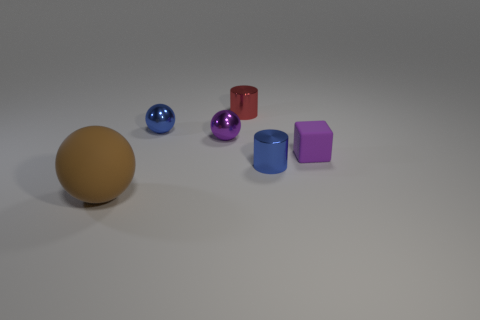Add 1 tiny purple objects. How many objects exist? 7 Subtract all blocks. How many objects are left? 5 Add 6 large rubber spheres. How many large rubber spheres are left? 7 Add 4 rubber objects. How many rubber objects exist? 6 Subtract 1 red cylinders. How many objects are left? 5 Subtract all blue metallic cylinders. Subtract all cubes. How many objects are left? 4 